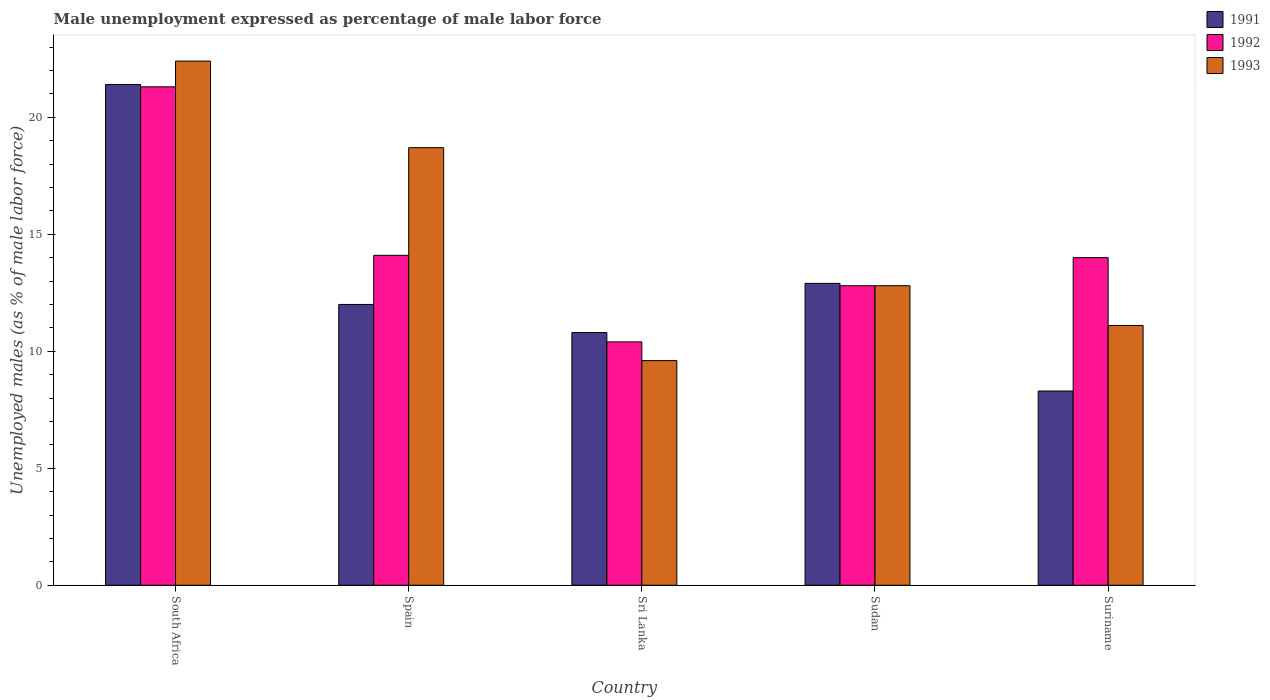How many different coloured bars are there?
Your answer should be very brief. 3. How many groups of bars are there?
Your response must be concise. 5. Are the number of bars per tick equal to the number of legend labels?
Keep it short and to the point. Yes. How many bars are there on the 5th tick from the left?
Your answer should be very brief. 3. How many bars are there on the 4th tick from the right?
Keep it short and to the point. 3. What is the label of the 1st group of bars from the left?
Your answer should be very brief. South Africa. What is the unemployment in males in in 1993 in Suriname?
Provide a short and direct response. 11.1. Across all countries, what is the maximum unemployment in males in in 1992?
Ensure brevity in your answer.  21.3. Across all countries, what is the minimum unemployment in males in in 1993?
Provide a succinct answer. 9.6. In which country was the unemployment in males in in 1993 maximum?
Offer a terse response. South Africa. In which country was the unemployment in males in in 1993 minimum?
Keep it short and to the point. Sri Lanka. What is the total unemployment in males in in 1992 in the graph?
Your answer should be very brief. 72.6. What is the difference between the unemployment in males in in 1993 in Spain and that in Suriname?
Give a very brief answer. 7.6. What is the difference between the unemployment in males in in 1992 in Sudan and the unemployment in males in in 1991 in South Africa?
Make the answer very short. -8.6. What is the average unemployment in males in in 1993 per country?
Your response must be concise. 14.92. What is the difference between the unemployment in males in of/in 1991 and unemployment in males in of/in 1992 in Suriname?
Offer a terse response. -5.7. What is the ratio of the unemployment in males in in 1992 in Spain to that in Sudan?
Keep it short and to the point. 1.1. Is the unemployment in males in in 1992 in Sri Lanka less than that in Suriname?
Keep it short and to the point. Yes. What is the difference between the highest and the second highest unemployment in males in in 1992?
Make the answer very short. 7.2. What is the difference between the highest and the lowest unemployment in males in in 1991?
Give a very brief answer. 13.1. In how many countries, is the unemployment in males in in 1993 greater than the average unemployment in males in in 1993 taken over all countries?
Make the answer very short. 2. What does the 3rd bar from the right in Spain represents?
Your answer should be very brief. 1991. How many bars are there?
Provide a succinct answer. 15. How many countries are there in the graph?
Give a very brief answer. 5. Are the values on the major ticks of Y-axis written in scientific E-notation?
Offer a very short reply. No. Does the graph contain any zero values?
Provide a succinct answer. No. Does the graph contain grids?
Make the answer very short. No. How many legend labels are there?
Keep it short and to the point. 3. How are the legend labels stacked?
Provide a short and direct response. Vertical. What is the title of the graph?
Make the answer very short. Male unemployment expressed as percentage of male labor force. What is the label or title of the Y-axis?
Offer a very short reply. Unemployed males (as % of male labor force). What is the Unemployed males (as % of male labor force) of 1991 in South Africa?
Your answer should be very brief. 21.4. What is the Unemployed males (as % of male labor force) in 1992 in South Africa?
Provide a succinct answer. 21.3. What is the Unemployed males (as % of male labor force) in 1993 in South Africa?
Offer a very short reply. 22.4. What is the Unemployed males (as % of male labor force) in 1991 in Spain?
Provide a short and direct response. 12. What is the Unemployed males (as % of male labor force) in 1992 in Spain?
Your answer should be very brief. 14.1. What is the Unemployed males (as % of male labor force) in 1993 in Spain?
Your answer should be very brief. 18.7. What is the Unemployed males (as % of male labor force) in 1991 in Sri Lanka?
Give a very brief answer. 10.8. What is the Unemployed males (as % of male labor force) of 1992 in Sri Lanka?
Give a very brief answer. 10.4. What is the Unemployed males (as % of male labor force) in 1993 in Sri Lanka?
Ensure brevity in your answer.  9.6. What is the Unemployed males (as % of male labor force) in 1991 in Sudan?
Your response must be concise. 12.9. What is the Unemployed males (as % of male labor force) in 1992 in Sudan?
Offer a very short reply. 12.8. What is the Unemployed males (as % of male labor force) of 1993 in Sudan?
Your answer should be very brief. 12.8. What is the Unemployed males (as % of male labor force) in 1991 in Suriname?
Make the answer very short. 8.3. What is the Unemployed males (as % of male labor force) in 1992 in Suriname?
Ensure brevity in your answer.  14. What is the Unemployed males (as % of male labor force) of 1993 in Suriname?
Provide a succinct answer. 11.1. Across all countries, what is the maximum Unemployed males (as % of male labor force) in 1991?
Ensure brevity in your answer.  21.4. Across all countries, what is the maximum Unemployed males (as % of male labor force) of 1992?
Offer a terse response. 21.3. Across all countries, what is the maximum Unemployed males (as % of male labor force) in 1993?
Your response must be concise. 22.4. Across all countries, what is the minimum Unemployed males (as % of male labor force) of 1991?
Provide a succinct answer. 8.3. Across all countries, what is the minimum Unemployed males (as % of male labor force) in 1992?
Provide a short and direct response. 10.4. Across all countries, what is the minimum Unemployed males (as % of male labor force) of 1993?
Give a very brief answer. 9.6. What is the total Unemployed males (as % of male labor force) in 1991 in the graph?
Offer a terse response. 65.4. What is the total Unemployed males (as % of male labor force) of 1992 in the graph?
Your answer should be very brief. 72.6. What is the total Unemployed males (as % of male labor force) in 1993 in the graph?
Your answer should be very brief. 74.6. What is the difference between the Unemployed males (as % of male labor force) in 1991 in South Africa and that in Spain?
Provide a succinct answer. 9.4. What is the difference between the Unemployed males (as % of male labor force) of 1993 in South Africa and that in Sri Lanka?
Provide a succinct answer. 12.8. What is the difference between the Unemployed males (as % of male labor force) in 1991 in South Africa and that in Sudan?
Make the answer very short. 8.5. What is the difference between the Unemployed males (as % of male labor force) in 1992 in South Africa and that in Sudan?
Offer a terse response. 8.5. What is the difference between the Unemployed males (as % of male labor force) in 1993 in South Africa and that in Suriname?
Your answer should be compact. 11.3. What is the difference between the Unemployed males (as % of male labor force) in 1992 in Spain and that in Sri Lanka?
Provide a short and direct response. 3.7. What is the difference between the Unemployed males (as % of male labor force) in 1993 in Spain and that in Sri Lanka?
Your answer should be compact. 9.1. What is the difference between the Unemployed males (as % of male labor force) of 1991 in Spain and that in Sudan?
Offer a very short reply. -0.9. What is the difference between the Unemployed males (as % of male labor force) of 1992 in Spain and that in Sudan?
Provide a succinct answer. 1.3. What is the difference between the Unemployed males (as % of male labor force) of 1993 in Spain and that in Suriname?
Keep it short and to the point. 7.6. What is the difference between the Unemployed males (as % of male labor force) of 1991 in Sri Lanka and that in Sudan?
Your answer should be compact. -2.1. What is the difference between the Unemployed males (as % of male labor force) of 1991 in Sri Lanka and that in Suriname?
Make the answer very short. 2.5. What is the difference between the Unemployed males (as % of male labor force) in 1992 in Sri Lanka and that in Suriname?
Provide a short and direct response. -3.6. What is the difference between the Unemployed males (as % of male labor force) of 1993 in Sri Lanka and that in Suriname?
Ensure brevity in your answer.  -1.5. What is the difference between the Unemployed males (as % of male labor force) in 1993 in Sudan and that in Suriname?
Offer a terse response. 1.7. What is the difference between the Unemployed males (as % of male labor force) of 1991 in South Africa and the Unemployed males (as % of male labor force) of 1992 in Spain?
Offer a terse response. 7.3. What is the difference between the Unemployed males (as % of male labor force) in 1992 in South Africa and the Unemployed males (as % of male labor force) in 1993 in Sri Lanka?
Offer a very short reply. 11.7. What is the difference between the Unemployed males (as % of male labor force) of 1992 in South Africa and the Unemployed males (as % of male labor force) of 1993 in Suriname?
Your answer should be compact. 10.2. What is the difference between the Unemployed males (as % of male labor force) of 1991 in Spain and the Unemployed males (as % of male labor force) of 1992 in Sri Lanka?
Provide a short and direct response. 1.6. What is the difference between the Unemployed males (as % of male labor force) of 1991 in Spain and the Unemployed males (as % of male labor force) of 1993 in Sudan?
Your answer should be compact. -0.8. What is the difference between the Unemployed males (as % of male labor force) of 1991 in Spain and the Unemployed males (as % of male labor force) of 1992 in Suriname?
Provide a succinct answer. -2. What is the difference between the Unemployed males (as % of male labor force) in 1991 in Spain and the Unemployed males (as % of male labor force) in 1993 in Suriname?
Make the answer very short. 0.9. What is the difference between the Unemployed males (as % of male labor force) in 1991 in Sri Lanka and the Unemployed males (as % of male labor force) in 1993 in Sudan?
Your answer should be very brief. -2. What is the difference between the Unemployed males (as % of male labor force) of 1992 in Sri Lanka and the Unemployed males (as % of male labor force) of 1993 in Sudan?
Offer a very short reply. -2.4. What is the difference between the Unemployed males (as % of male labor force) of 1991 in Sri Lanka and the Unemployed males (as % of male labor force) of 1993 in Suriname?
Your answer should be compact. -0.3. What is the difference between the Unemployed males (as % of male labor force) in 1991 in Sudan and the Unemployed males (as % of male labor force) in 1992 in Suriname?
Provide a succinct answer. -1.1. What is the difference between the Unemployed males (as % of male labor force) of 1991 in Sudan and the Unemployed males (as % of male labor force) of 1993 in Suriname?
Offer a very short reply. 1.8. What is the average Unemployed males (as % of male labor force) of 1991 per country?
Provide a short and direct response. 13.08. What is the average Unemployed males (as % of male labor force) of 1992 per country?
Keep it short and to the point. 14.52. What is the average Unemployed males (as % of male labor force) in 1993 per country?
Offer a terse response. 14.92. What is the difference between the Unemployed males (as % of male labor force) in 1992 and Unemployed males (as % of male labor force) in 1993 in South Africa?
Offer a very short reply. -1.1. What is the difference between the Unemployed males (as % of male labor force) in 1991 and Unemployed males (as % of male labor force) in 1992 in Spain?
Your response must be concise. -2.1. What is the difference between the Unemployed males (as % of male labor force) of 1992 and Unemployed males (as % of male labor force) of 1993 in Spain?
Your response must be concise. -4.6. What is the difference between the Unemployed males (as % of male labor force) of 1991 and Unemployed males (as % of male labor force) of 1992 in Sri Lanka?
Ensure brevity in your answer.  0.4. What is the difference between the Unemployed males (as % of male labor force) of 1992 and Unemployed males (as % of male labor force) of 1993 in Sri Lanka?
Offer a terse response. 0.8. What is the difference between the Unemployed males (as % of male labor force) in 1991 and Unemployed males (as % of male labor force) in 1992 in Sudan?
Offer a terse response. 0.1. What is the difference between the Unemployed males (as % of male labor force) of 1991 and Unemployed males (as % of male labor force) of 1993 in Suriname?
Your answer should be very brief. -2.8. What is the difference between the Unemployed males (as % of male labor force) in 1992 and Unemployed males (as % of male labor force) in 1993 in Suriname?
Ensure brevity in your answer.  2.9. What is the ratio of the Unemployed males (as % of male labor force) of 1991 in South Africa to that in Spain?
Offer a terse response. 1.78. What is the ratio of the Unemployed males (as % of male labor force) of 1992 in South Africa to that in Spain?
Keep it short and to the point. 1.51. What is the ratio of the Unemployed males (as % of male labor force) in 1993 in South Africa to that in Spain?
Ensure brevity in your answer.  1.2. What is the ratio of the Unemployed males (as % of male labor force) in 1991 in South Africa to that in Sri Lanka?
Offer a very short reply. 1.98. What is the ratio of the Unemployed males (as % of male labor force) in 1992 in South Africa to that in Sri Lanka?
Keep it short and to the point. 2.05. What is the ratio of the Unemployed males (as % of male labor force) of 1993 in South Africa to that in Sri Lanka?
Keep it short and to the point. 2.33. What is the ratio of the Unemployed males (as % of male labor force) in 1991 in South Africa to that in Sudan?
Provide a short and direct response. 1.66. What is the ratio of the Unemployed males (as % of male labor force) of 1992 in South Africa to that in Sudan?
Offer a very short reply. 1.66. What is the ratio of the Unemployed males (as % of male labor force) of 1991 in South Africa to that in Suriname?
Give a very brief answer. 2.58. What is the ratio of the Unemployed males (as % of male labor force) of 1992 in South Africa to that in Suriname?
Your response must be concise. 1.52. What is the ratio of the Unemployed males (as % of male labor force) of 1993 in South Africa to that in Suriname?
Your response must be concise. 2.02. What is the ratio of the Unemployed males (as % of male labor force) in 1991 in Spain to that in Sri Lanka?
Make the answer very short. 1.11. What is the ratio of the Unemployed males (as % of male labor force) in 1992 in Spain to that in Sri Lanka?
Make the answer very short. 1.36. What is the ratio of the Unemployed males (as % of male labor force) in 1993 in Spain to that in Sri Lanka?
Your answer should be very brief. 1.95. What is the ratio of the Unemployed males (as % of male labor force) of 1991 in Spain to that in Sudan?
Give a very brief answer. 0.93. What is the ratio of the Unemployed males (as % of male labor force) of 1992 in Spain to that in Sudan?
Provide a succinct answer. 1.1. What is the ratio of the Unemployed males (as % of male labor force) in 1993 in Spain to that in Sudan?
Your answer should be very brief. 1.46. What is the ratio of the Unemployed males (as % of male labor force) in 1991 in Spain to that in Suriname?
Give a very brief answer. 1.45. What is the ratio of the Unemployed males (as % of male labor force) of 1992 in Spain to that in Suriname?
Provide a succinct answer. 1.01. What is the ratio of the Unemployed males (as % of male labor force) in 1993 in Spain to that in Suriname?
Keep it short and to the point. 1.68. What is the ratio of the Unemployed males (as % of male labor force) in 1991 in Sri Lanka to that in Sudan?
Make the answer very short. 0.84. What is the ratio of the Unemployed males (as % of male labor force) in 1992 in Sri Lanka to that in Sudan?
Ensure brevity in your answer.  0.81. What is the ratio of the Unemployed males (as % of male labor force) of 1991 in Sri Lanka to that in Suriname?
Your answer should be compact. 1.3. What is the ratio of the Unemployed males (as % of male labor force) in 1992 in Sri Lanka to that in Suriname?
Provide a short and direct response. 0.74. What is the ratio of the Unemployed males (as % of male labor force) of 1993 in Sri Lanka to that in Suriname?
Provide a short and direct response. 0.86. What is the ratio of the Unemployed males (as % of male labor force) in 1991 in Sudan to that in Suriname?
Ensure brevity in your answer.  1.55. What is the ratio of the Unemployed males (as % of male labor force) in 1992 in Sudan to that in Suriname?
Your response must be concise. 0.91. What is the ratio of the Unemployed males (as % of male labor force) of 1993 in Sudan to that in Suriname?
Ensure brevity in your answer.  1.15. What is the difference between the highest and the second highest Unemployed males (as % of male labor force) in 1992?
Keep it short and to the point. 7.2. What is the difference between the highest and the lowest Unemployed males (as % of male labor force) of 1992?
Provide a succinct answer. 10.9. What is the difference between the highest and the lowest Unemployed males (as % of male labor force) of 1993?
Your response must be concise. 12.8. 